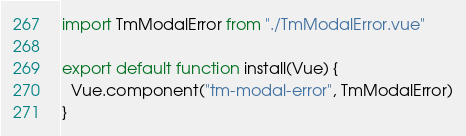<code> <loc_0><loc_0><loc_500><loc_500><_JavaScript_>import TmModalError from "./TmModalError.vue"

export default function install(Vue) {
  Vue.component("tm-modal-error", TmModalError)
}
</code> 